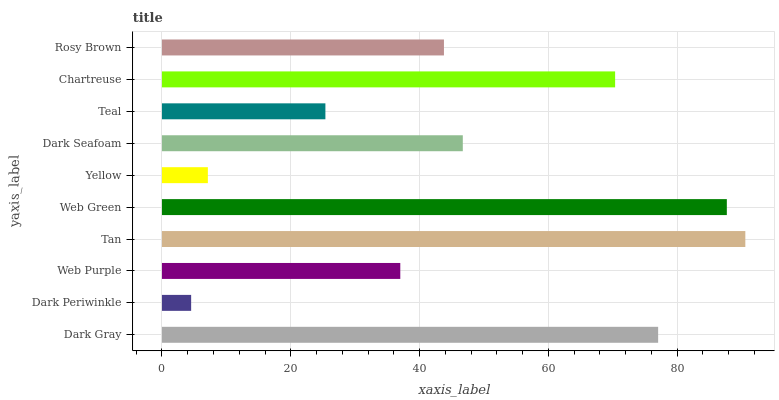Is Dark Periwinkle the minimum?
Answer yes or no. Yes. Is Tan the maximum?
Answer yes or no. Yes. Is Web Purple the minimum?
Answer yes or no. No. Is Web Purple the maximum?
Answer yes or no. No. Is Web Purple greater than Dark Periwinkle?
Answer yes or no. Yes. Is Dark Periwinkle less than Web Purple?
Answer yes or no. Yes. Is Dark Periwinkle greater than Web Purple?
Answer yes or no. No. Is Web Purple less than Dark Periwinkle?
Answer yes or no. No. Is Dark Seafoam the high median?
Answer yes or no. Yes. Is Rosy Brown the low median?
Answer yes or no. Yes. Is Tan the high median?
Answer yes or no. No. Is Chartreuse the low median?
Answer yes or no. No. 